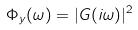<formula> <loc_0><loc_0><loc_500><loc_500>\Phi _ { y } ( \omega ) = | G ( i \omega ) | ^ { 2 }</formula> 